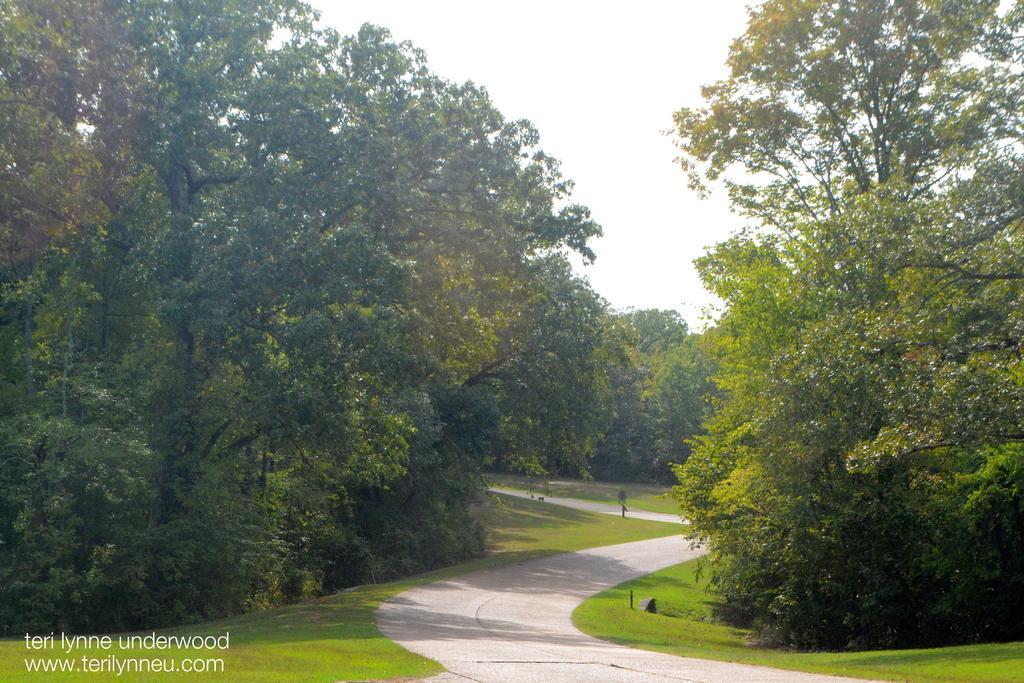Can you describe this image briefly? In this picture we can see a path, beside this path we can see metal poles, grass, trees and we can see sky in the background, in the bottom left we can see some text on it. 